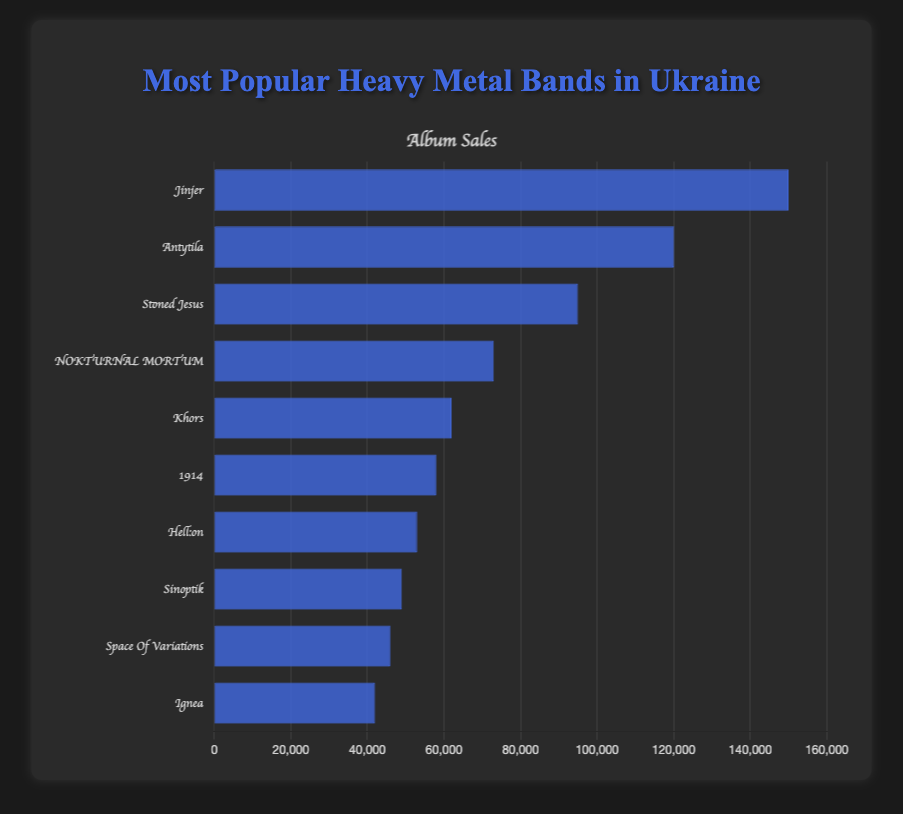Which band had the highest album sales? To find the band with the highest album sales, look for the tallest bar. Jinjer has the tallest bar indicating the highest album sales.
Answer: Jinjer How many albums did NOKTURNAL MORTUM sell? Locate the bar representing NOKTURNAL MORTUM, then refer to its height to determine the number of album sales. It aligns with the value of 73,000.
Answer: 73,000 Compare the album sales of Khors and 1914. Which band sold more albums? Identify the bars representing Khors and 1914. The height of Khors's bar is greater than 1914's, indicating Khors sold more albums. 62,000 vs. 58,000.
Answer: Khors What's the total album sales of the top three bands? Sum the album sales of Jinjer (150,000), Antytila (120,000), and Stoned Jesus (95,000). 150,000 + 120,000 + 95,000 equals 365,000.
Answer: 365,000 What's the difference in album sales between the band with the highest sales and Ignea? Subtract the album sales of Ignea (42,000) from Jinjer's (150,000). 150,000 - 42,000 equals 108,000.
Answer: 108,000 Identify the band with the smallest album sales. Look for the shortest bar in the chart. The bar for Ignea is the shortest, indicating the smallest album sales.
Answer: Ignea Which bands sold between 50,000 and 100,000 albums? Identify the bars whose heights correspond to album sales in this range. The bands are Stoned Jesus (95,000), NOKTURNAL MORTUM (73,000), Khors (62,000), 1914 (58,000), and Hell:on (53,000).
Answer: Stoned Jesus, NOKTURNAL MORTUM, Khors, 1914, Hell:on If the album sales of Space Of Variations and Sinoptik are combined, what's the total? Add their album sales: Space Of Variations (46,000) and Sinoptik (49,000). 46,000 + 49,000 equals 95,000.
Answer: 95,000 Which band(s) are closest to the median album sales value? Order the sales values and identify the middle one(s). In this case: Median of {42,000, 46,000, 49,000, 53,000, 58,000, 62,000, 73,000, 95,000, 120,000, 150,000} is 57,000. Closest bands are 1914 (58,000).
Answer: 1914 What is the average album sales of all ten bands? Calculate the sum of all album sales, then divide by the number of bands. Sum: 150,000 + 120,000 + 95,000 + 73,000 + 62,000 + 58,000 + 53,000 + 49,000 + 46,000 + 42,000 = 748,000. Average: 748,000 / 10 = 74,800.
Answer: 74,800 